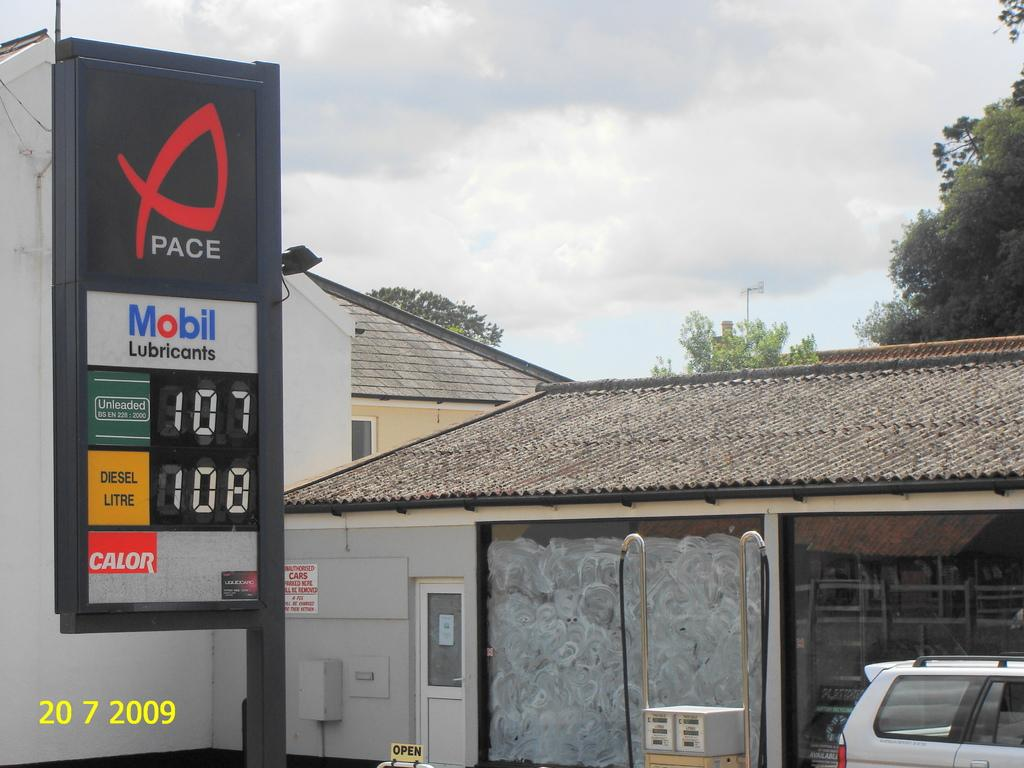What can be seen in the sky in the image? The sky with clouds is visible in the image. What type of natural elements are present in the image? There are trees in the image. What type of man-made structures can be seen in the image? There are buildings in the image. What type of electronic device is present in the image? A display screen is present in the image. What type of commercial content is visible in the image? Advertisements are visible in the image. What type of transportation is on the road in the image? A motor vehicle is on the road in the image. How many spiders are crawling on the display screen in the image? There are no spiders present in the image, and therefore no such activity can be observed. What is the reaction of the motor vehicle to the advertisements in the image? The motor vehicle is not capable of having a reaction, as it is an inanimate object. 